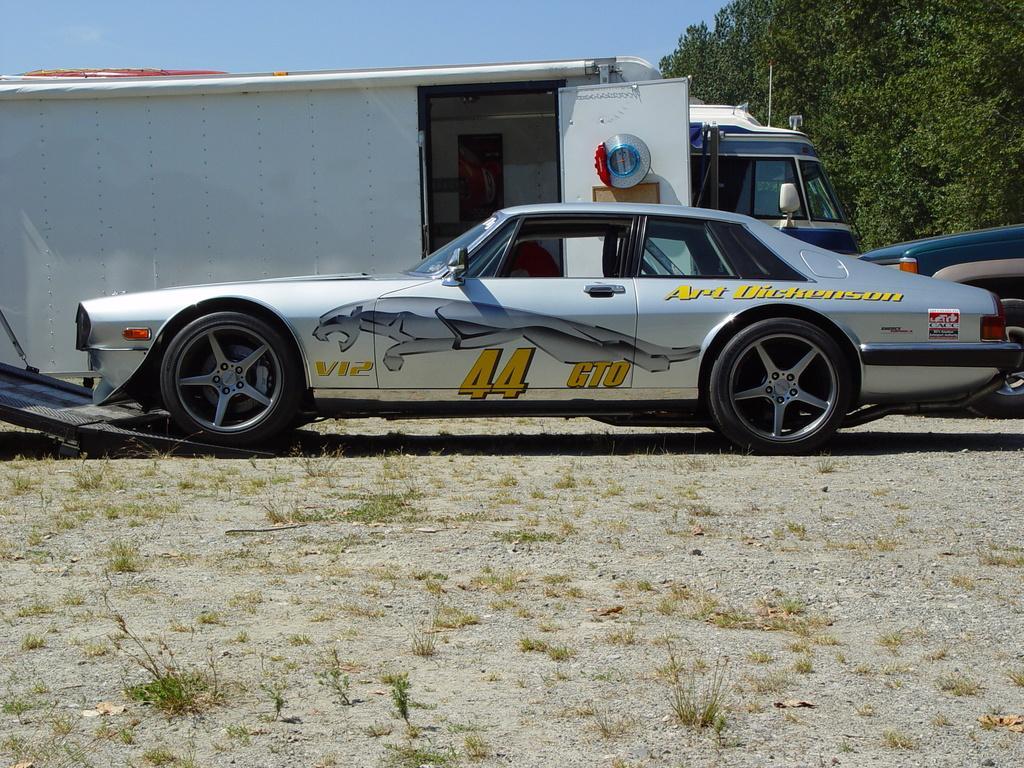Could you give a brief overview of what you see in this image? In this picture we can see vehicles and grass on the ground and in the background we can see trees, sky. 